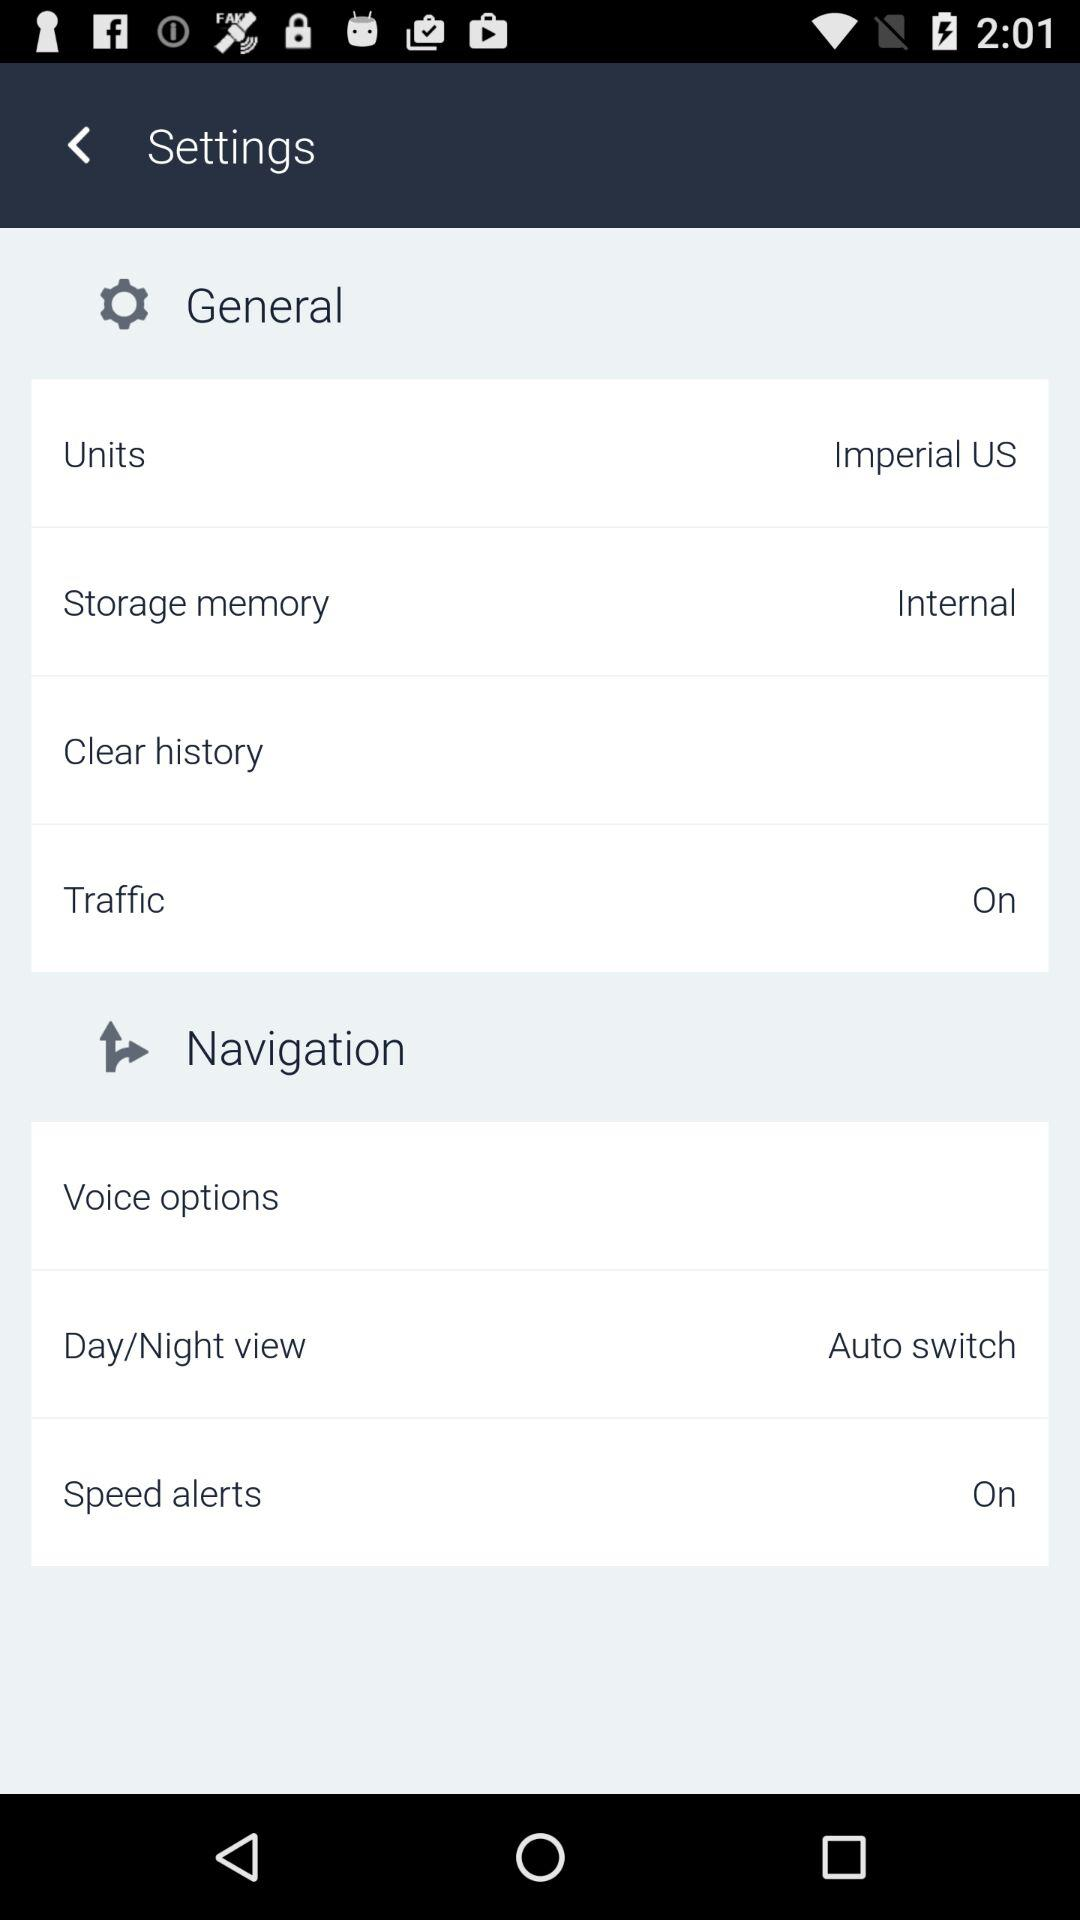What is the current status of the "Traffic"? The current status is "on". 